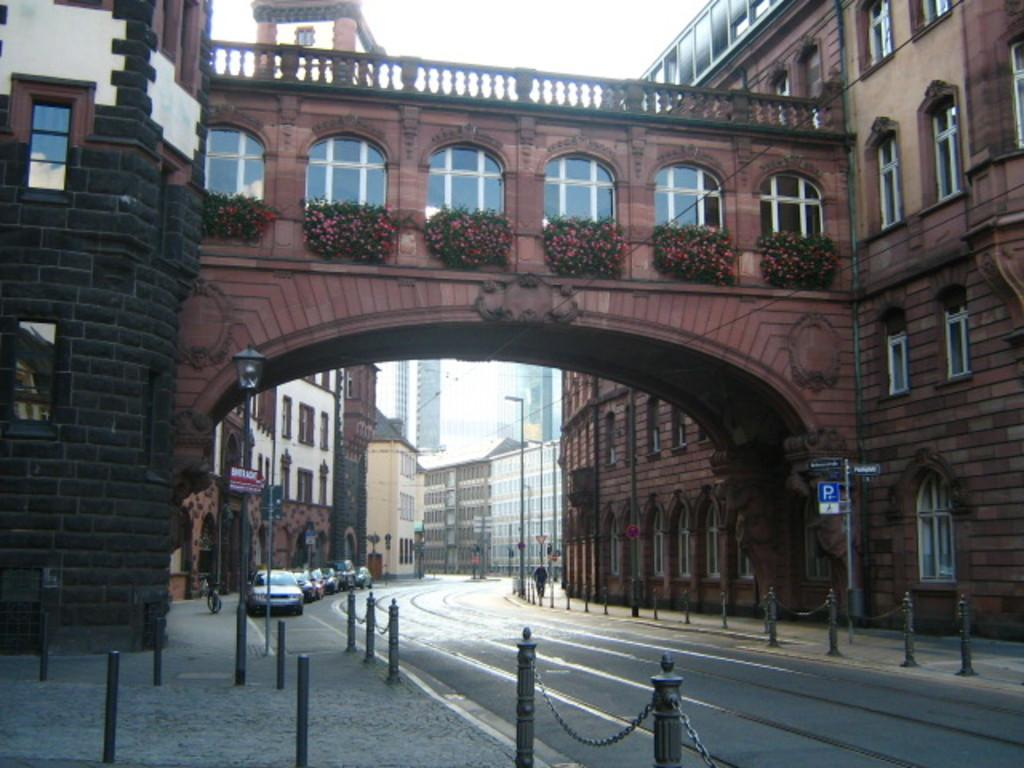What types of vehicles are at the bottom of the image? There are cars at the bottom of the image. What structures are present at the bottom of the image? Street lights and poles are visible at the bottom of the image. What safety feature is in the image? Safety poles are present in the image. Who is present at the bottom of the image? People are present at the bottom of the image. What type of pathway is at the bottom of the image? There is a road at the bottom of the image. What can be seen in the buildings at the top of the image? Windows are present in the buildings. What type of vegetation is visible in the image? Plants are visible in the image. What is visible at the top of the image? The sky is visible at the top of the image. What type of home does the carpenter live in, as seen in the image? There is no carpenter or home present in the image. What type of tail is attached to the safety poles in the image? There are no tails present in the image, as the safety poles are not animals. 